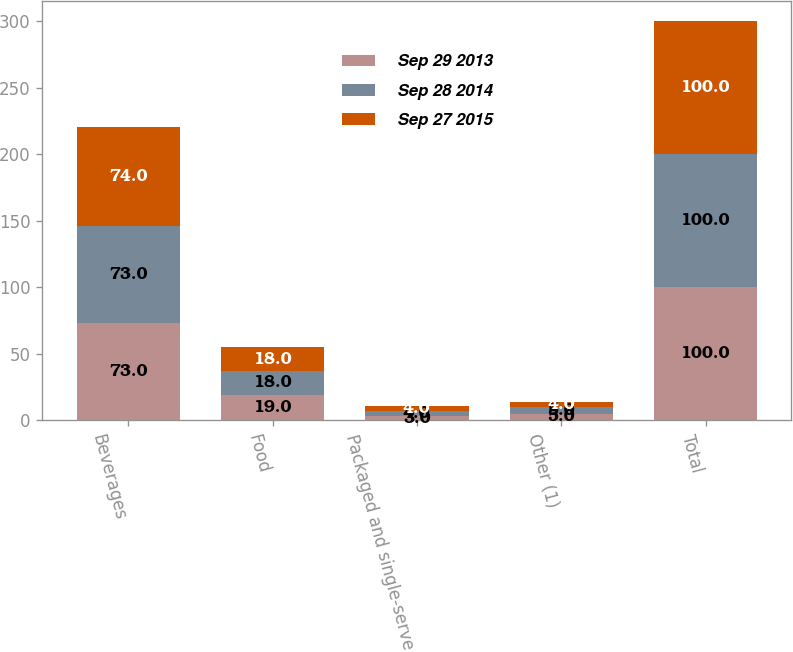<chart> <loc_0><loc_0><loc_500><loc_500><stacked_bar_chart><ecel><fcel>Beverages<fcel>Food<fcel>Packaged and single-serve<fcel>Other (1)<fcel>Total<nl><fcel>Sep 29 2013<fcel>73<fcel>19<fcel>3<fcel>5<fcel>100<nl><fcel>Sep 28 2014<fcel>73<fcel>18<fcel>4<fcel>5<fcel>100<nl><fcel>Sep 27 2015<fcel>74<fcel>18<fcel>4<fcel>4<fcel>100<nl></chart> 